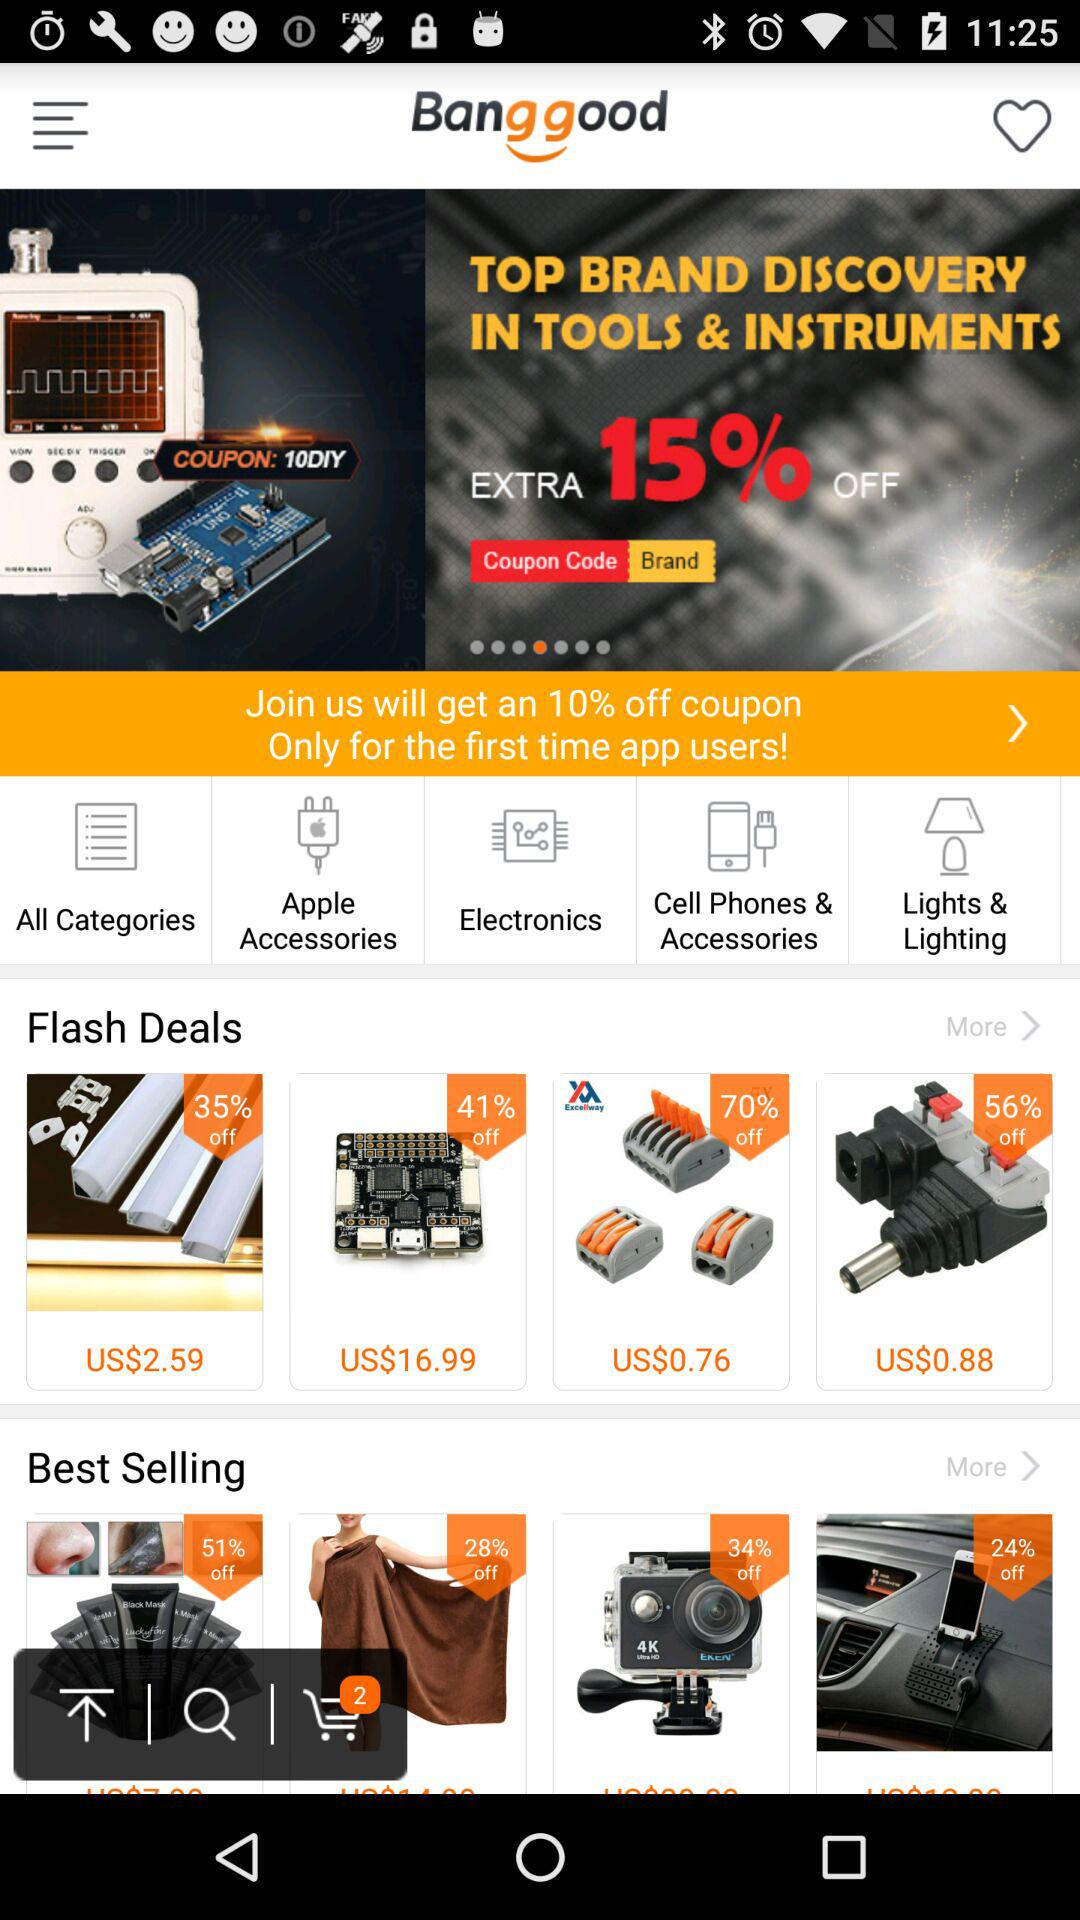What is the cost of the item having a 56% discount? The cost of the item is US$0.88. 